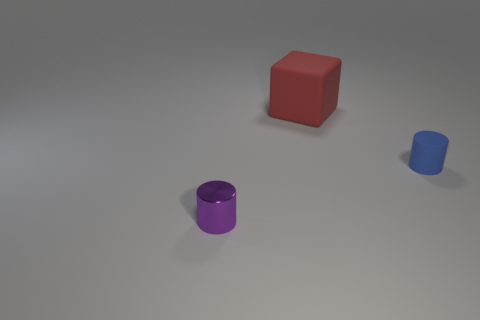Add 1 red cubes. How many objects exist? 4 Subtract all blue cylinders. How many cylinders are left? 1 Subtract 1 blocks. How many blocks are left? 0 Subtract all brown blocks. Subtract all purple cylinders. How many blocks are left? 1 Subtract all cylinders. How many objects are left? 1 Subtract all tiny cylinders. Subtract all tiny blue rubber cylinders. How many objects are left? 0 Add 2 small purple shiny things. How many small purple shiny things are left? 3 Add 1 cyan metal spheres. How many cyan metal spheres exist? 1 Subtract 0 purple spheres. How many objects are left? 3 